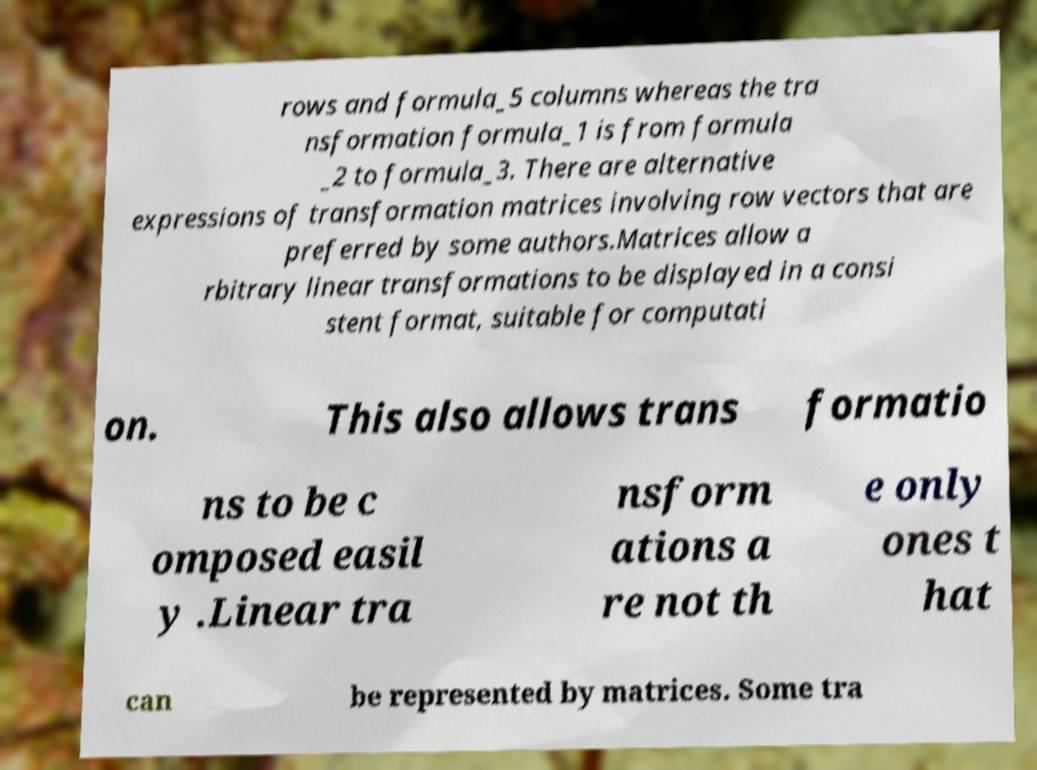Could you extract and type out the text from this image? rows and formula_5 columns whereas the tra nsformation formula_1 is from formula _2 to formula_3. There are alternative expressions of transformation matrices involving row vectors that are preferred by some authors.Matrices allow a rbitrary linear transformations to be displayed in a consi stent format, suitable for computati on. This also allows trans formatio ns to be c omposed easil y .Linear tra nsform ations a re not th e only ones t hat can be represented by matrices. Some tra 